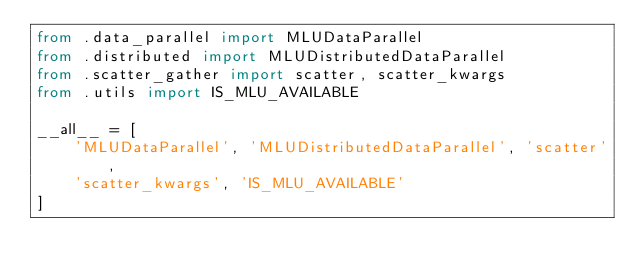Convert code to text. <code><loc_0><loc_0><loc_500><loc_500><_Python_>from .data_parallel import MLUDataParallel
from .distributed import MLUDistributedDataParallel
from .scatter_gather import scatter, scatter_kwargs
from .utils import IS_MLU_AVAILABLE

__all__ = [
    'MLUDataParallel', 'MLUDistributedDataParallel', 'scatter',
    'scatter_kwargs', 'IS_MLU_AVAILABLE'
]
</code> 